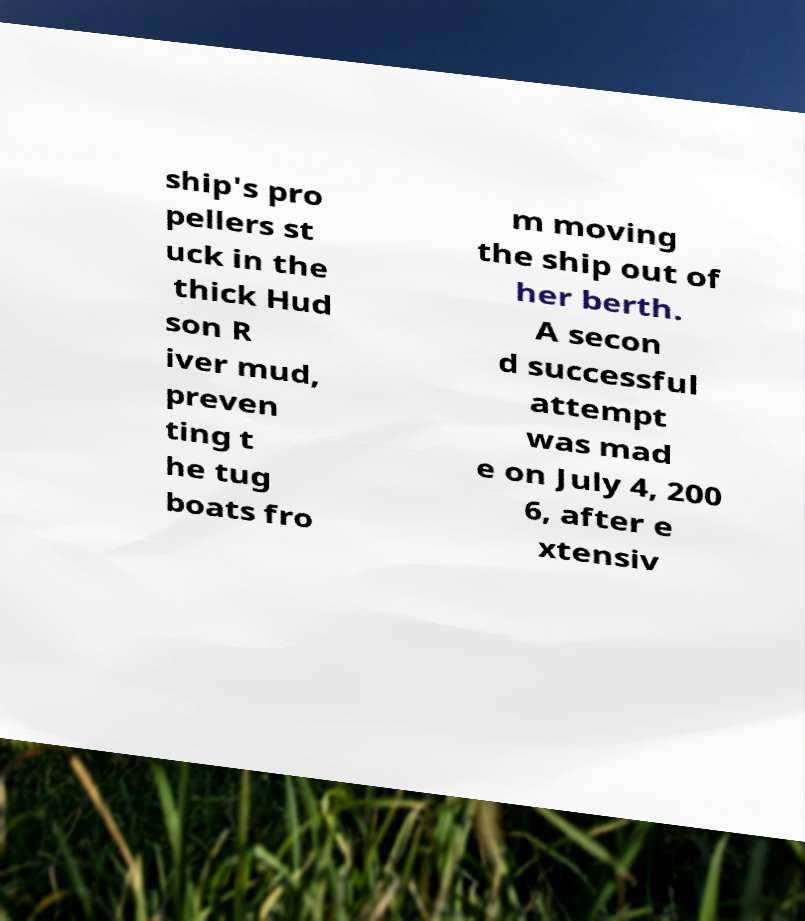What messages or text are displayed in this image? I need them in a readable, typed format. ship's pro pellers st uck in the thick Hud son R iver mud, preven ting t he tug boats fro m moving the ship out of her berth. A secon d successful attempt was mad e on July 4, 200 6, after e xtensiv 